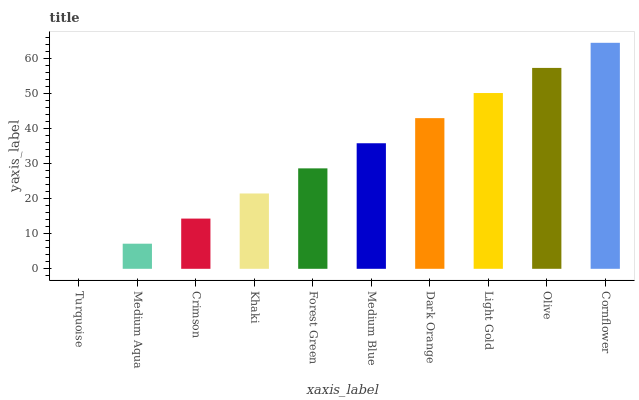Is Medium Aqua the minimum?
Answer yes or no. No. Is Medium Aqua the maximum?
Answer yes or no. No. Is Medium Aqua greater than Turquoise?
Answer yes or no. Yes. Is Turquoise less than Medium Aqua?
Answer yes or no. Yes. Is Turquoise greater than Medium Aqua?
Answer yes or no. No. Is Medium Aqua less than Turquoise?
Answer yes or no. No. Is Medium Blue the high median?
Answer yes or no. Yes. Is Forest Green the low median?
Answer yes or no. Yes. Is Crimson the high median?
Answer yes or no. No. Is Medium Blue the low median?
Answer yes or no. No. 